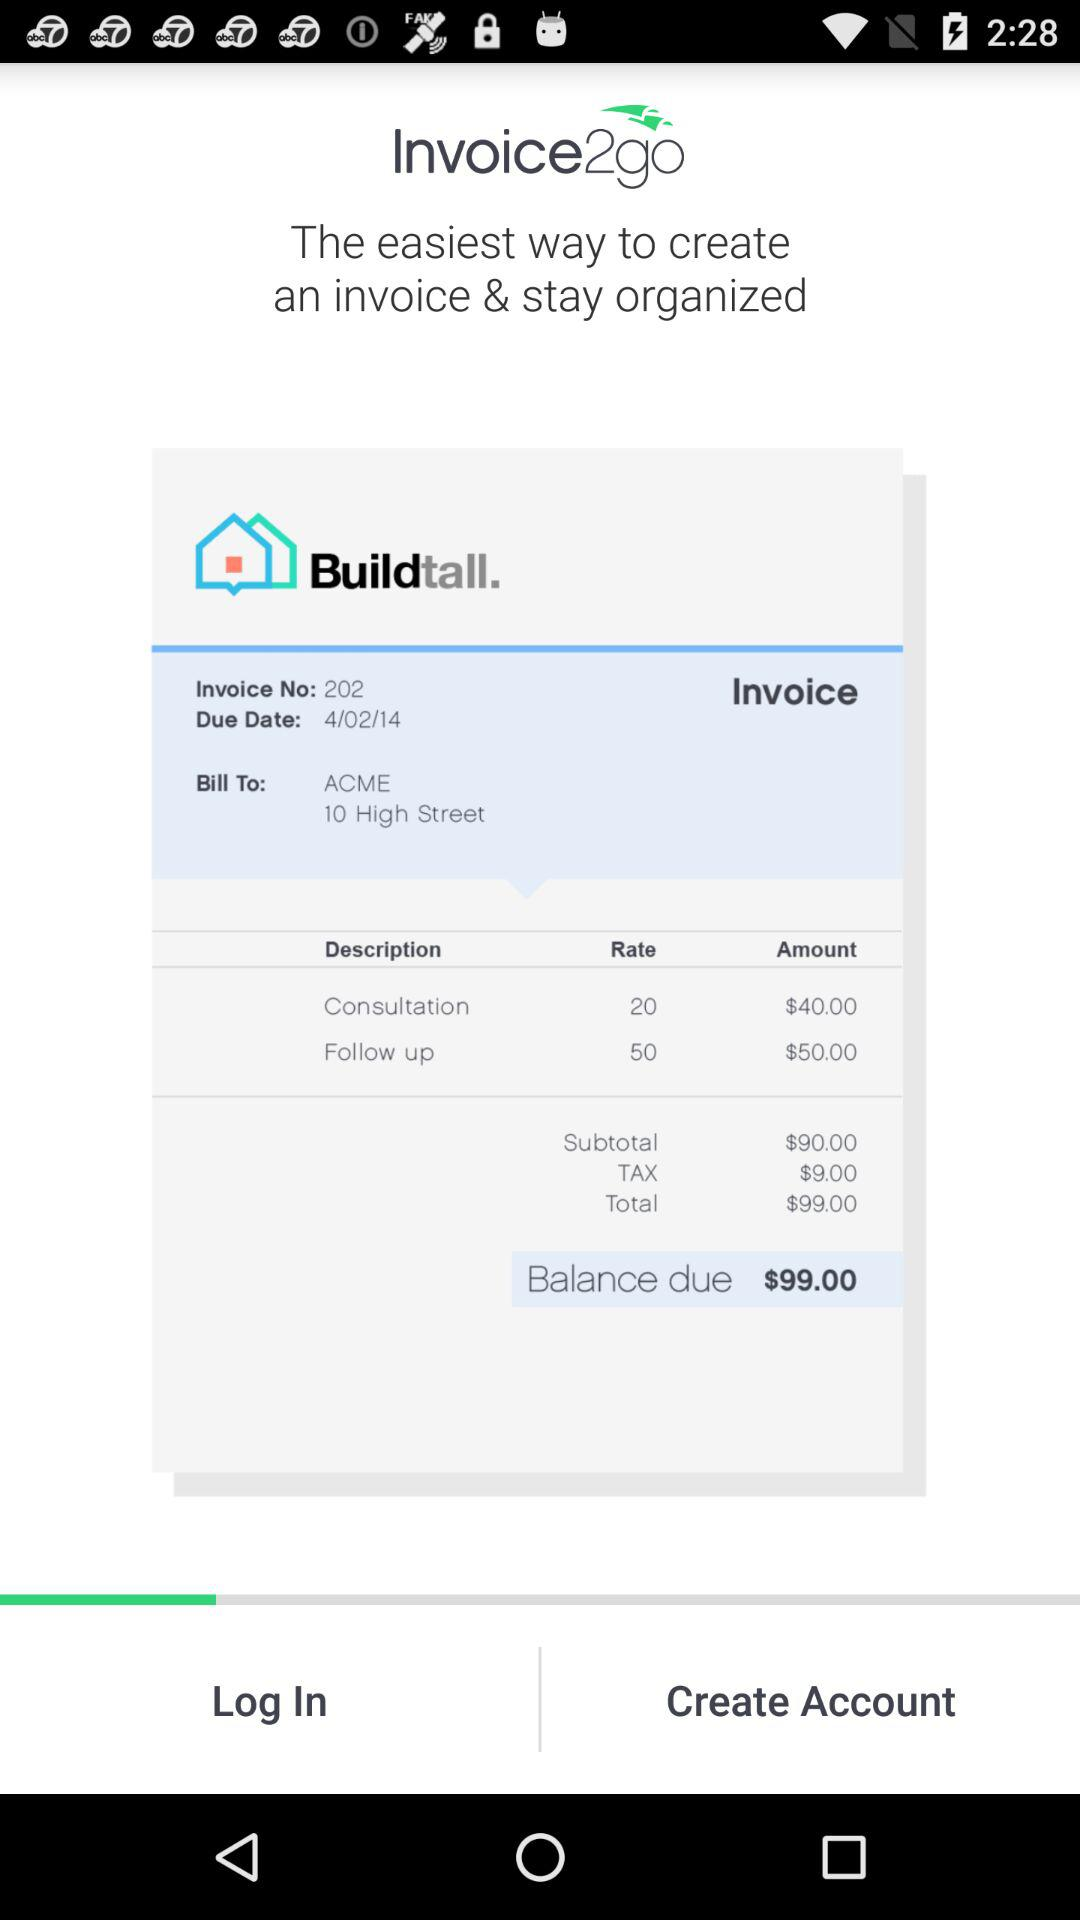What is the invoice number? The invoice number is 202. 